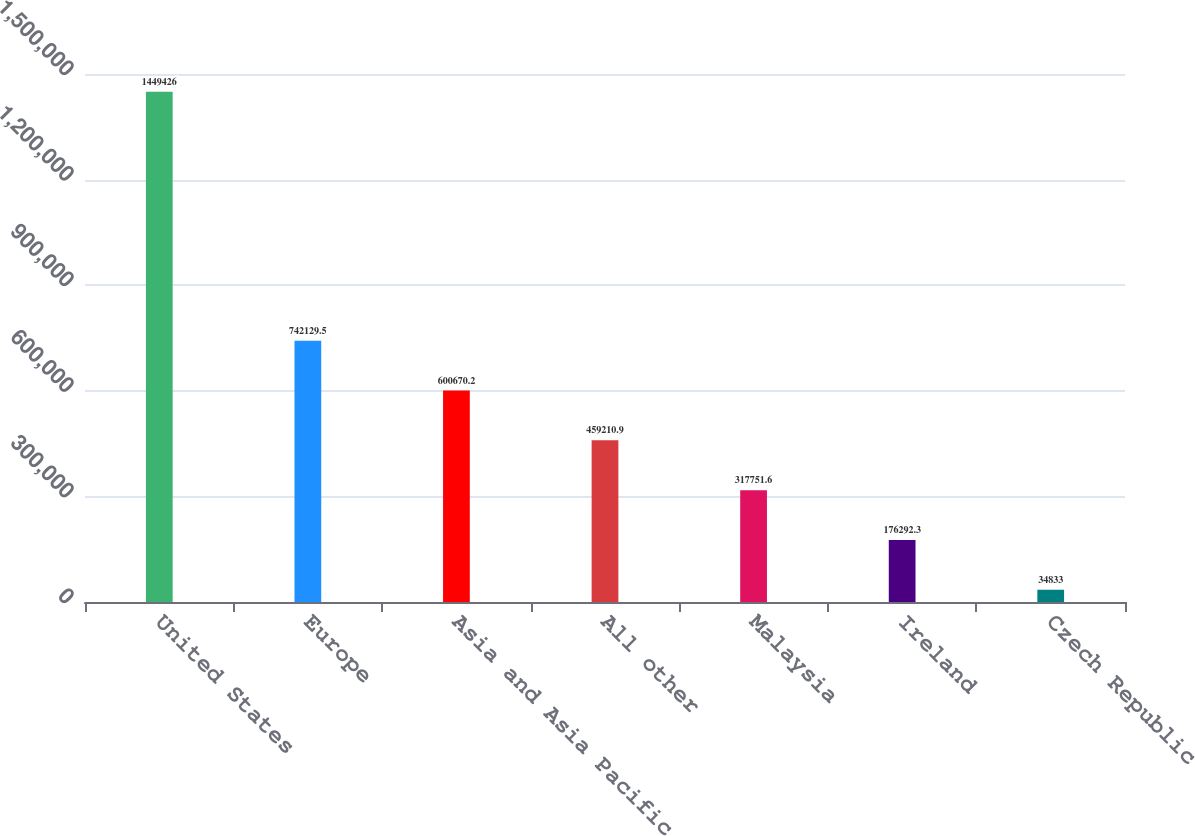Convert chart to OTSL. <chart><loc_0><loc_0><loc_500><loc_500><bar_chart><fcel>United States<fcel>Europe<fcel>Asia and Asia Pacific<fcel>All other<fcel>Malaysia<fcel>Ireland<fcel>Czech Republic<nl><fcel>1.44943e+06<fcel>742130<fcel>600670<fcel>459211<fcel>317752<fcel>176292<fcel>34833<nl></chart> 